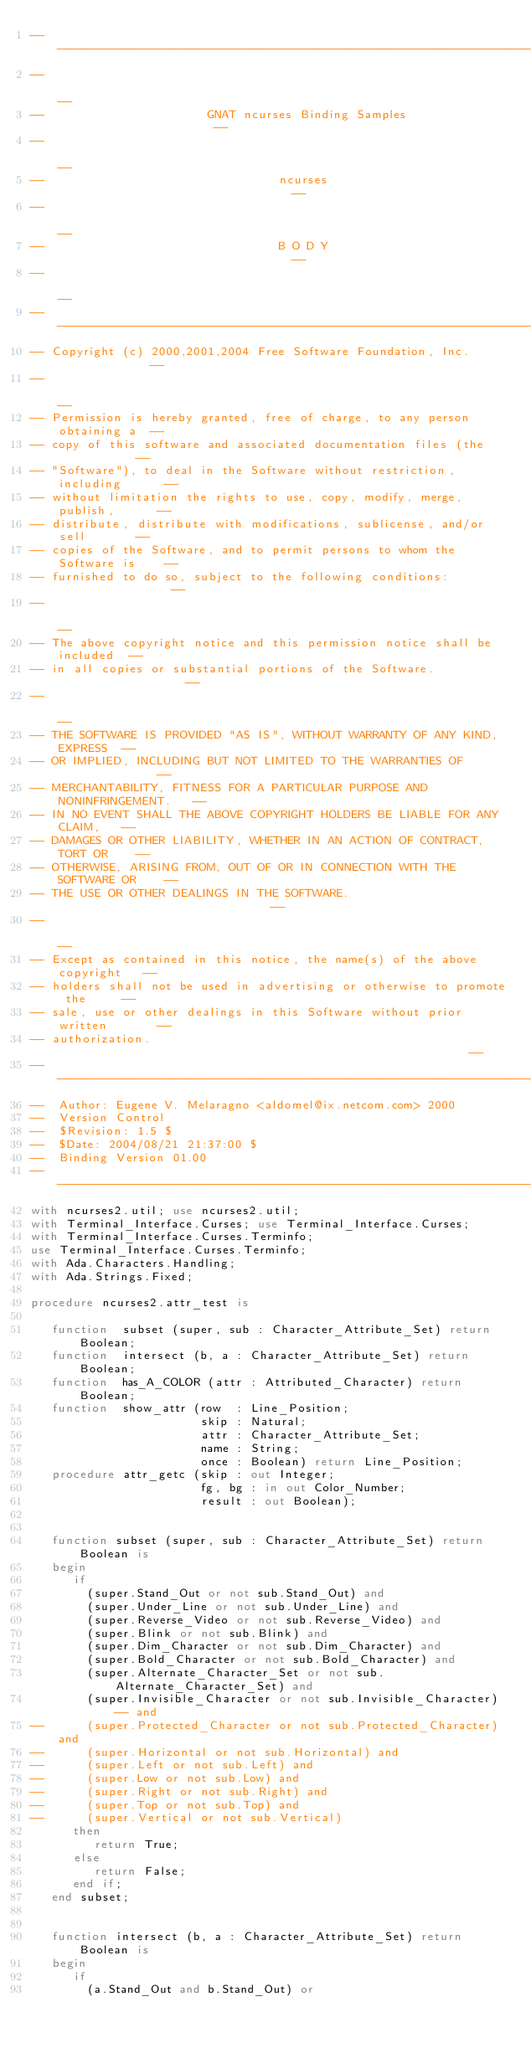<code> <loc_0><loc_0><loc_500><loc_500><_Ada_>------------------------------------------------------------------------------
--                                                                          --
--                       GNAT ncurses Binding Samples                       --
--                                                                          --
--                                 ncurses                                  --
--                                                                          --
--                                 B O D Y                                  --
--                                                                          --
------------------------------------------------------------------------------
-- Copyright (c) 2000,2001,2004 Free Software Foundation, Inc.              --
--                                                                          --
-- Permission is hereby granted, free of charge, to any person obtaining a  --
-- copy of this software and associated documentation files (the            --
-- "Software"), to deal in the Software without restriction, including      --
-- without limitation the rights to use, copy, modify, merge, publish,      --
-- distribute, distribute with modifications, sublicense, and/or sell       --
-- copies of the Software, and to permit persons to whom the Software is    --
-- furnished to do so, subject to the following conditions:                 --
--                                                                          --
-- The above copyright notice and this permission notice shall be included  --
-- in all copies or substantial portions of the Software.                   --
--                                                                          --
-- THE SOFTWARE IS PROVIDED "AS IS", WITHOUT WARRANTY OF ANY KIND, EXPRESS  --
-- OR IMPLIED, INCLUDING BUT NOT LIMITED TO THE WARRANTIES OF               --
-- MERCHANTABILITY, FITNESS FOR A PARTICULAR PURPOSE AND NONINFRINGEMENT.   --
-- IN NO EVENT SHALL THE ABOVE COPYRIGHT HOLDERS BE LIABLE FOR ANY CLAIM,   --
-- DAMAGES OR OTHER LIABILITY, WHETHER IN AN ACTION OF CONTRACT, TORT OR    --
-- OTHERWISE, ARISING FROM, OUT OF OR IN CONNECTION WITH THE SOFTWARE OR    --
-- THE USE OR OTHER DEALINGS IN THE SOFTWARE.                               --
--                                                                          --
-- Except as contained in this notice, the name(s) of the above copyright   --
-- holders shall not be used in advertising or otherwise to promote the     --
-- sale, use or other dealings in this Software without prior written       --
-- authorization.                                                           --
------------------------------------------------------------------------------
--  Author: Eugene V. Melaragno <aldomel@ix.netcom.com> 2000
--  Version Control
--  $Revision: 1.5 $
--  $Date: 2004/08/21 21:37:00 $
--  Binding Version 01.00
------------------------------------------------------------------------------
with ncurses2.util; use ncurses2.util;
with Terminal_Interface.Curses; use Terminal_Interface.Curses;
with Terminal_Interface.Curses.Terminfo;
use Terminal_Interface.Curses.Terminfo;
with Ada.Characters.Handling;
with Ada.Strings.Fixed;

procedure ncurses2.attr_test is

   function  subset (super, sub : Character_Attribute_Set) return Boolean;
   function  intersect (b, a : Character_Attribute_Set) return Boolean;
   function  has_A_COLOR (attr : Attributed_Character) return Boolean;
   function  show_attr (row  : Line_Position;
                        skip : Natural;
                        attr : Character_Attribute_Set;
                        name : String;
                        once : Boolean) return Line_Position;
   procedure attr_getc (skip : out Integer;
                        fg, bg : in out Color_Number;
                        result : out Boolean);


   function subset (super, sub : Character_Attribute_Set) return Boolean is
   begin
      if
        (super.Stand_Out or not sub.Stand_Out) and
        (super.Under_Line or not sub.Under_Line) and
        (super.Reverse_Video or not sub.Reverse_Video) and
        (super.Blink or not sub.Blink) and
        (super.Dim_Character or not sub.Dim_Character) and
        (super.Bold_Character or not sub.Bold_Character) and
        (super.Alternate_Character_Set or not sub.Alternate_Character_Set) and
        (super.Invisible_Character or not sub.Invisible_Character) -- and
--      (super.Protected_Character or not sub.Protected_Character) and
--      (super.Horizontal or not sub.Horizontal) and
--      (super.Left or not sub.Left) and
--      (super.Low or not sub.Low) and
--      (super.Right or not sub.Right) and
--      (super.Top or not sub.Top) and
--      (super.Vertical or not sub.Vertical)
      then
         return True;
      else
         return False;
      end if;
   end subset;


   function intersect (b, a : Character_Attribute_Set) return Boolean is
   begin
      if
        (a.Stand_Out and b.Stand_Out) or</code> 